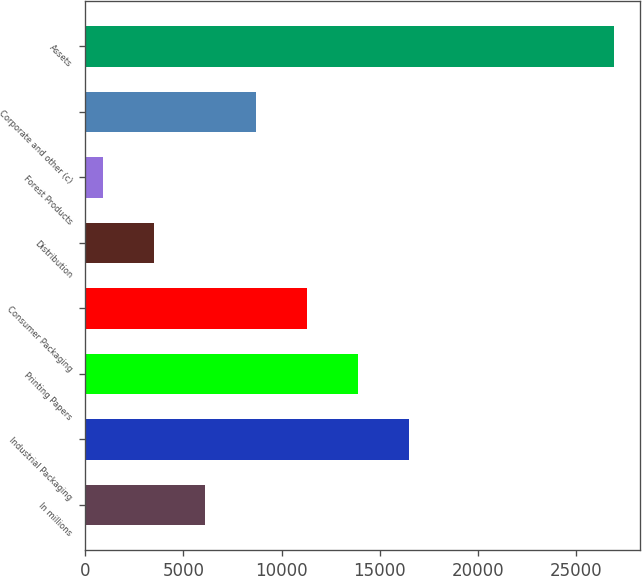Convert chart to OTSL. <chart><loc_0><loc_0><loc_500><loc_500><bar_chart><fcel>In millions<fcel>Industrial Packaging<fcel>Printing Papers<fcel>Consumer Packaging<fcel>Distribution<fcel>Forest Products<fcel>Corporate and other (c)<fcel>Assets<nl><fcel>6105<fcel>16509<fcel>13908<fcel>11307<fcel>3504<fcel>903<fcel>8706<fcel>26913<nl></chart> 